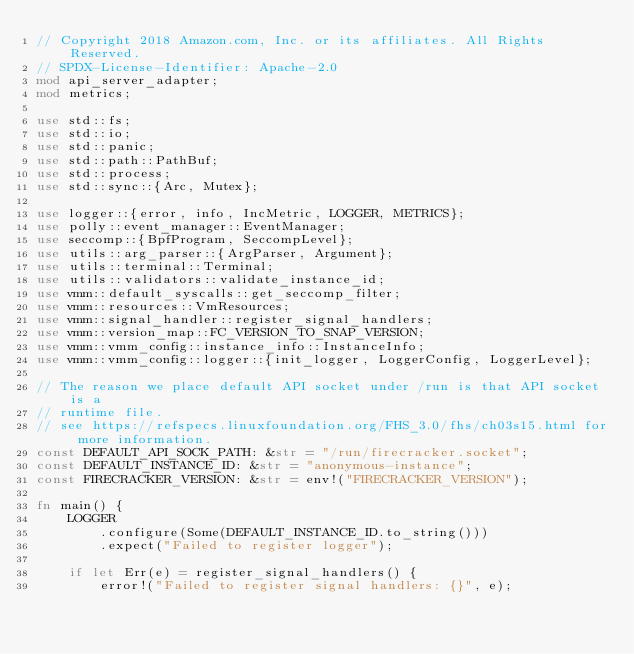<code> <loc_0><loc_0><loc_500><loc_500><_Rust_>// Copyright 2018 Amazon.com, Inc. or its affiliates. All Rights Reserved.
// SPDX-License-Identifier: Apache-2.0
mod api_server_adapter;
mod metrics;

use std::fs;
use std::io;
use std::panic;
use std::path::PathBuf;
use std::process;
use std::sync::{Arc, Mutex};

use logger::{error, info, IncMetric, LOGGER, METRICS};
use polly::event_manager::EventManager;
use seccomp::{BpfProgram, SeccompLevel};
use utils::arg_parser::{ArgParser, Argument};
use utils::terminal::Terminal;
use utils::validators::validate_instance_id;
use vmm::default_syscalls::get_seccomp_filter;
use vmm::resources::VmResources;
use vmm::signal_handler::register_signal_handlers;
use vmm::version_map::FC_VERSION_TO_SNAP_VERSION;
use vmm::vmm_config::instance_info::InstanceInfo;
use vmm::vmm_config::logger::{init_logger, LoggerConfig, LoggerLevel};

// The reason we place default API socket under /run is that API socket is a
// runtime file.
// see https://refspecs.linuxfoundation.org/FHS_3.0/fhs/ch03s15.html for more information.
const DEFAULT_API_SOCK_PATH: &str = "/run/firecracker.socket";
const DEFAULT_INSTANCE_ID: &str = "anonymous-instance";
const FIRECRACKER_VERSION: &str = env!("FIRECRACKER_VERSION");

fn main() {
    LOGGER
        .configure(Some(DEFAULT_INSTANCE_ID.to_string()))
        .expect("Failed to register logger");

    if let Err(e) = register_signal_handlers() {
        error!("Failed to register signal handlers: {}", e);</code> 